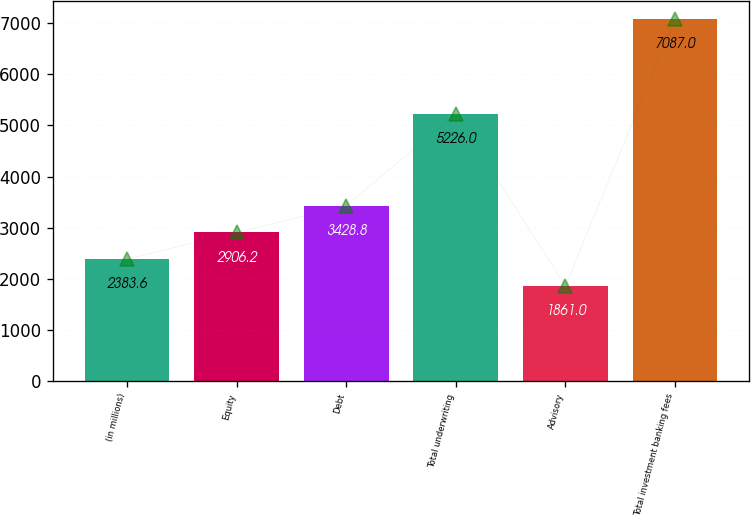Convert chart. <chart><loc_0><loc_0><loc_500><loc_500><bar_chart><fcel>(in millions)<fcel>Equity<fcel>Debt<fcel>Total underwriting<fcel>Advisory<fcel>Total investment banking fees<nl><fcel>2383.6<fcel>2906.2<fcel>3428.8<fcel>5226<fcel>1861<fcel>7087<nl></chart> 